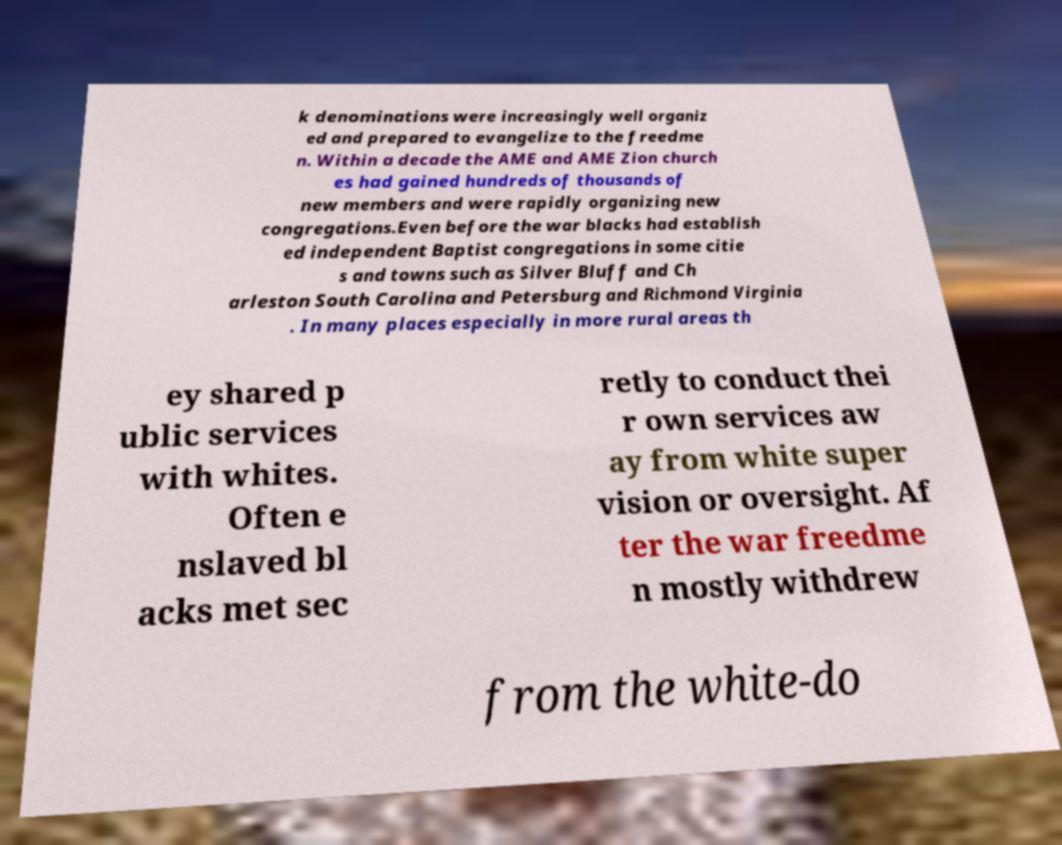Could you assist in decoding the text presented in this image and type it out clearly? k denominations were increasingly well organiz ed and prepared to evangelize to the freedme n. Within a decade the AME and AME Zion church es had gained hundreds of thousands of new members and were rapidly organizing new congregations.Even before the war blacks had establish ed independent Baptist congregations in some citie s and towns such as Silver Bluff and Ch arleston South Carolina and Petersburg and Richmond Virginia . In many places especially in more rural areas th ey shared p ublic services with whites. Often e nslaved bl acks met sec retly to conduct thei r own services aw ay from white super vision or oversight. Af ter the war freedme n mostly withdrew from the white-do 